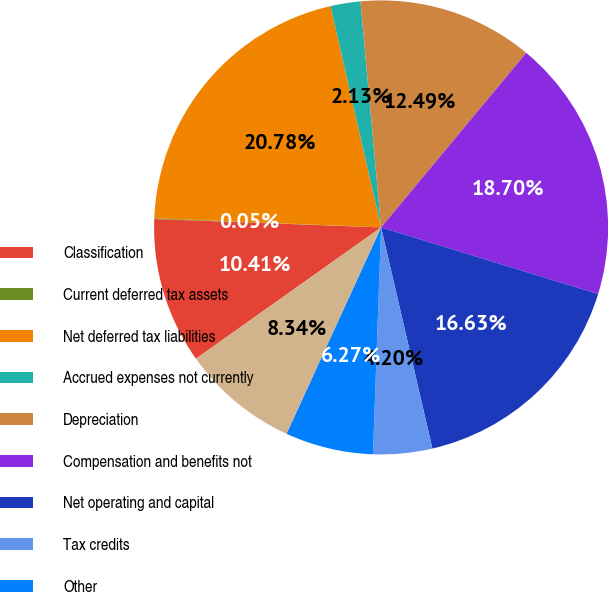Convert chart to OTSL. <chart><loc_0><loc_0><loc_500><loc_500><pie_chart><fcel>Classification<fcel>Current deferred tax assets<fcel>Net deferred tax liabilities<fcel>Accrued expenses not currently<fcel>Depreciation<fcel>Compensation and benefits not<fcel>Net operating and capital<fcel>Tax credits<fcel>Other<fcel>Less Valuation allowances<nl><fcel>10.41%<fcel>0.05%<fcel>20.78%<fcel>2.13%<fcel>12.49%<fcel>18.7%<fcel>16.63%<fcel>4.2%<fcel>6.27%<fcel>8.34%<nl></chart> 